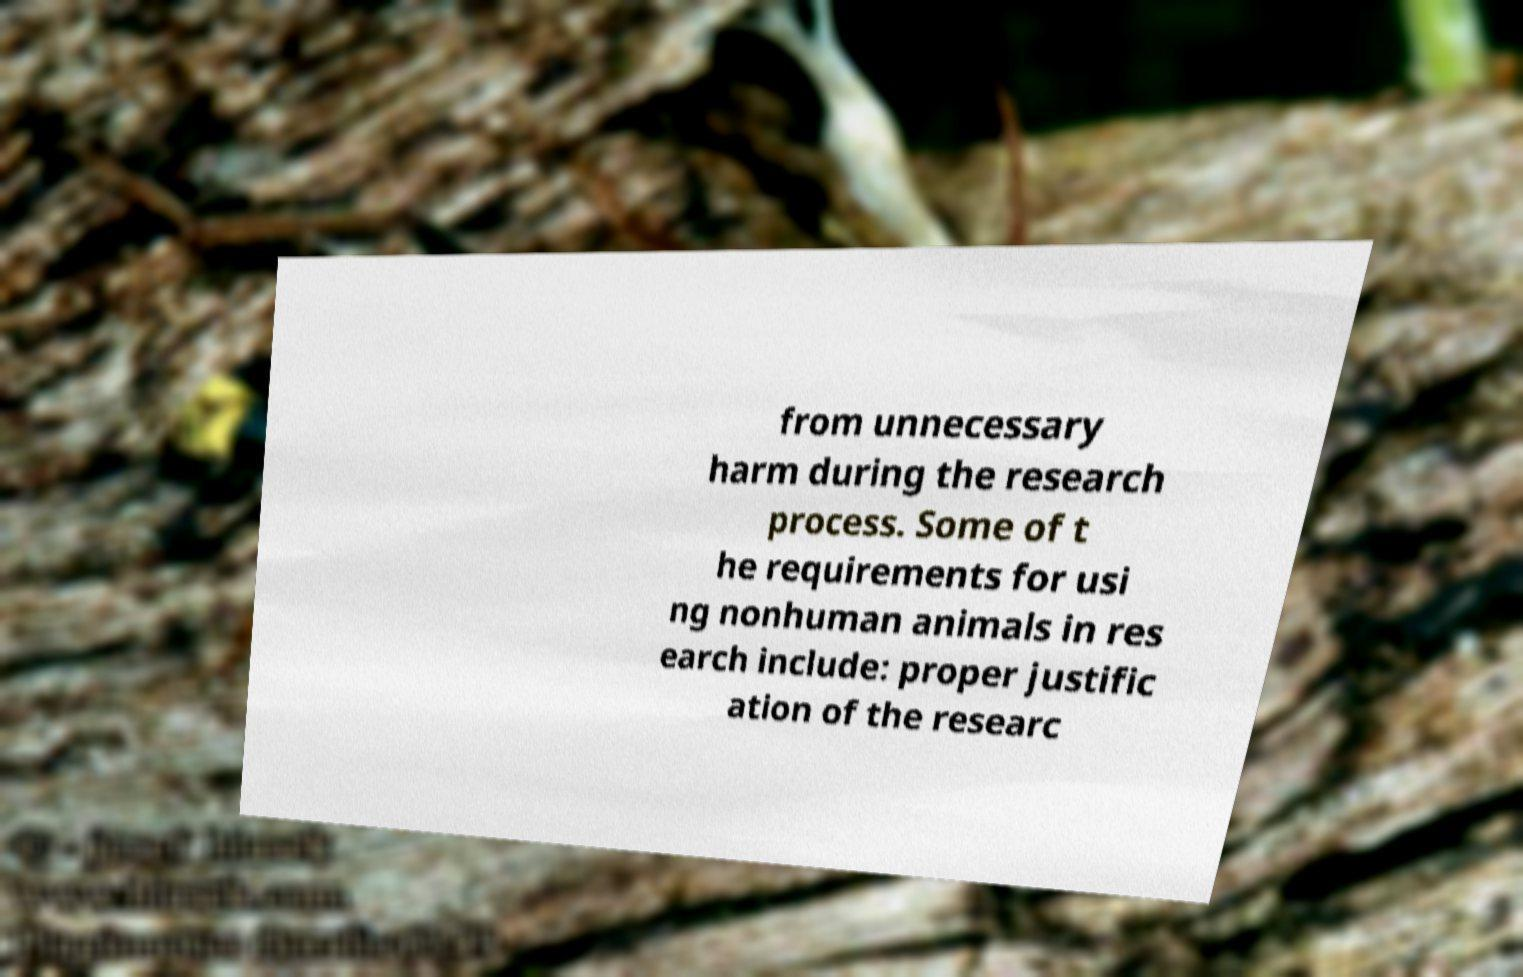Can you accurately transcribe the text from the provided image for me? from unnecessary harm during the research process. Some of t he requirements for usi ng nonhuman animals in res earch include: proper justific ation of the researc 